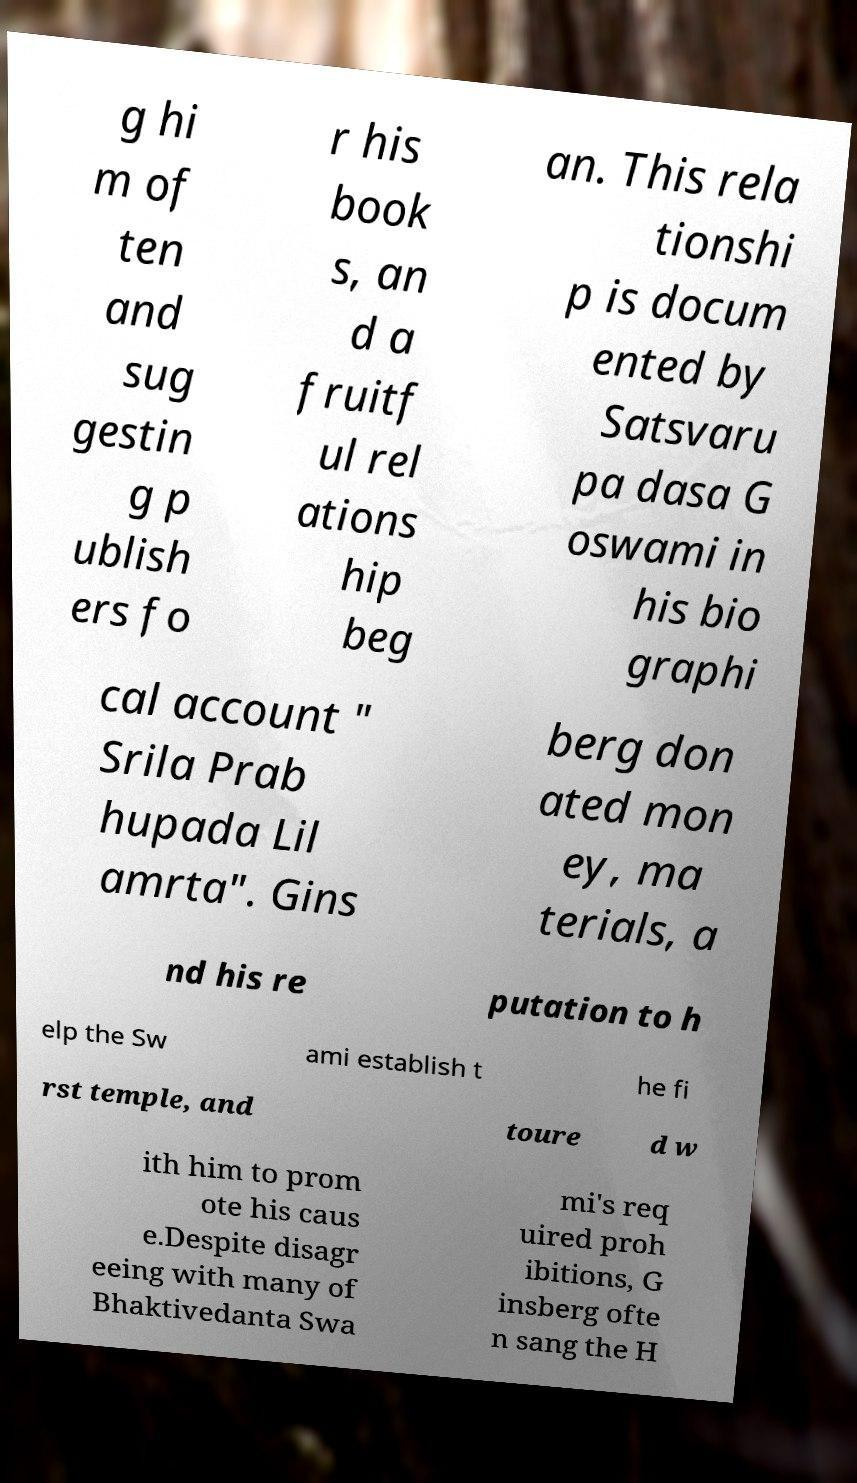Please read and relay the text visible in this image. What does it say? g hi m of ten and sug gestin g p ublish ers fo r his book s, an d a fruitf ul rel ations hip beg an. This rela tionshi p is docum ented by Satsvaru pa dasa G oswami in his bio graphi cal account " Srila Prab hupada Lil amrta". Gins berg don ated mon ey, ma terials, a nd his re putation to h elp the Sw ami establish t he fi rst temple, and toure d w ith him to prom ote his caus e.Despite disagr eeing with many of Bhaktivedanta Swa mi's req uired proh ibitions, G insberg ofte n sang the H 